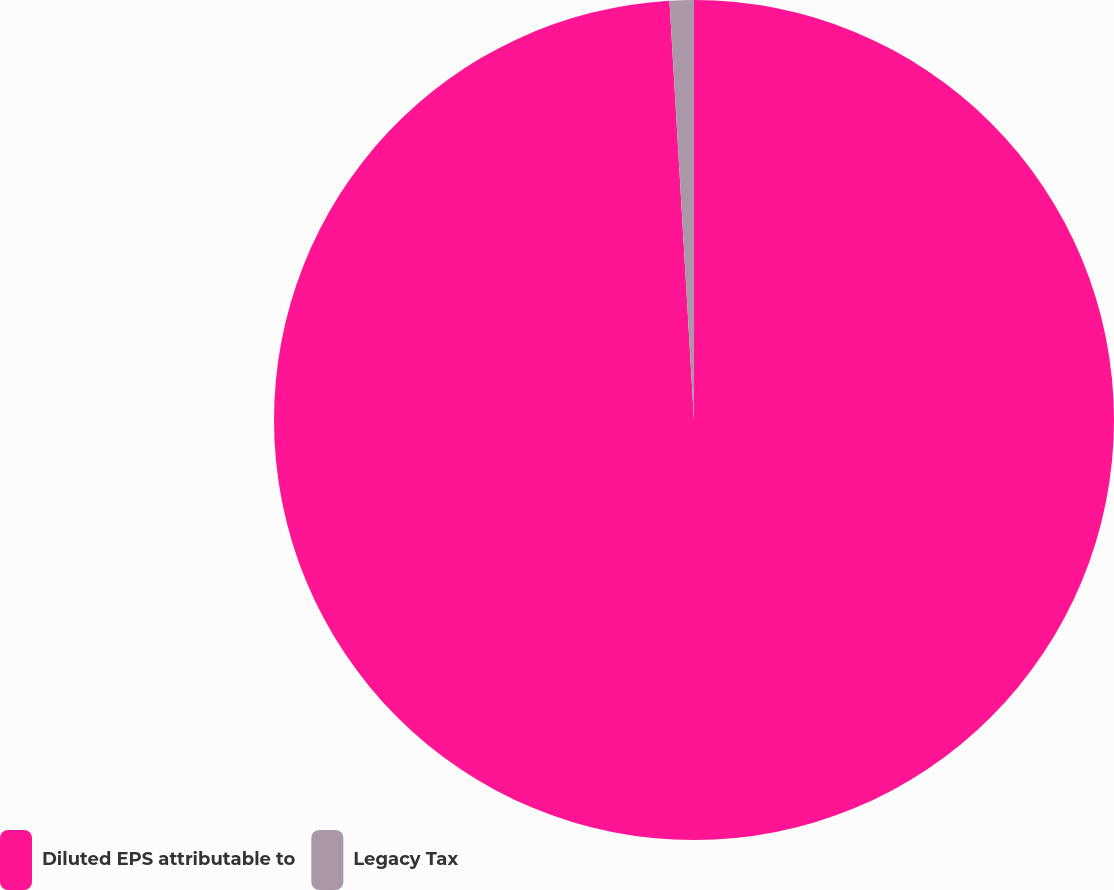Convert chart to OTSL. <chart><loc_0><loc_0><loc_500><loc_500><pie_chart><fcel>Diluted EPS attributable to<fcel>Legacy Tax<nl><fcel>99.07%<fcel>0.93%<nl></chart> 